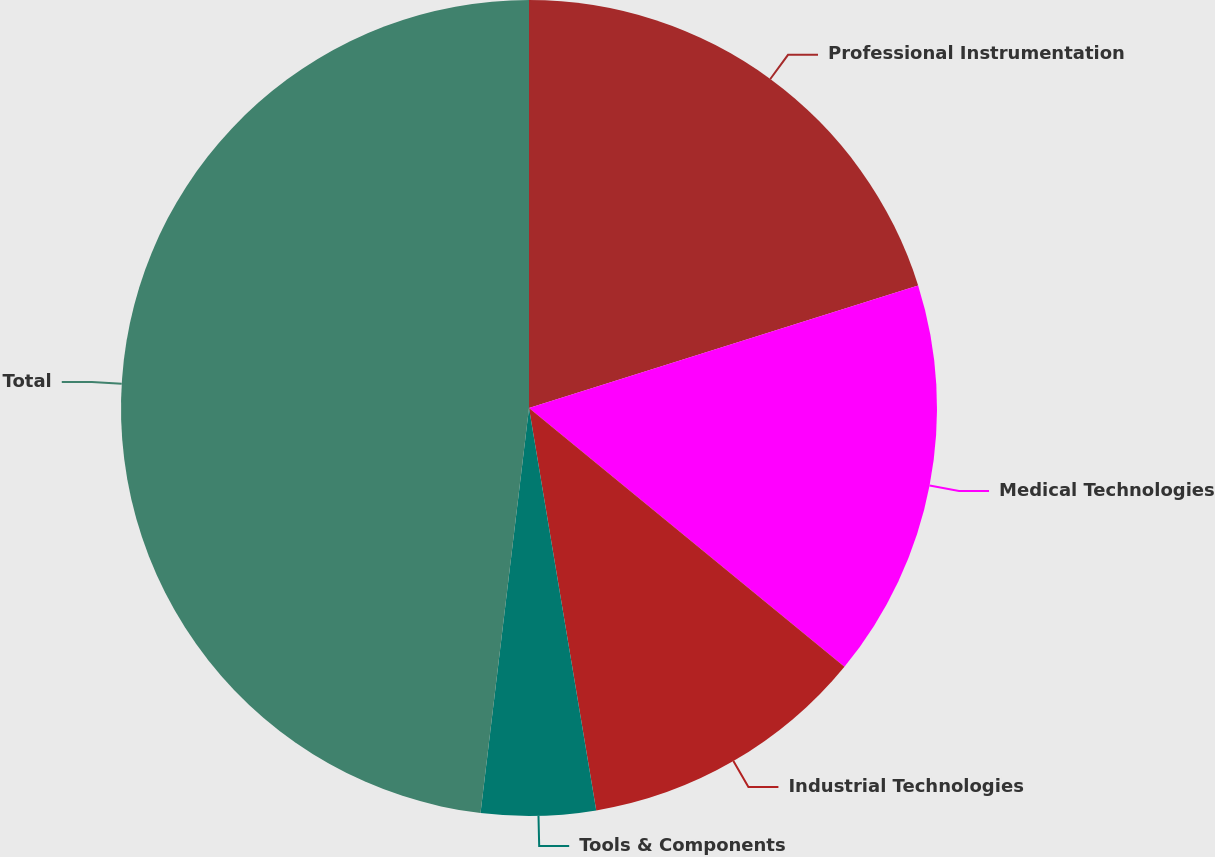<chart> <loc_0><loc_0><loc_500><loc_500><pie_chart><fcel>Professional Instrumentation<fcel>Medical Technologies<fcel>Industrial Technologies<fcel>Tools & Components<fcel>Total<nl><fcel>20.14%<fcel>15.79%<fcel>11.43%<fcel>4.53%<fcel>48.1%<nl></chart> 